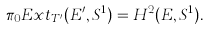<formula> <loc_0><loc_0><loc_500><loc_500>\pi _ { 0 } E x t _ { T ^ { \prime } } ( E ^ { \prime } , S ^ { 1 } ) = H ^ { 2 } ( E , S ^ { 1 } ) .</formula> 